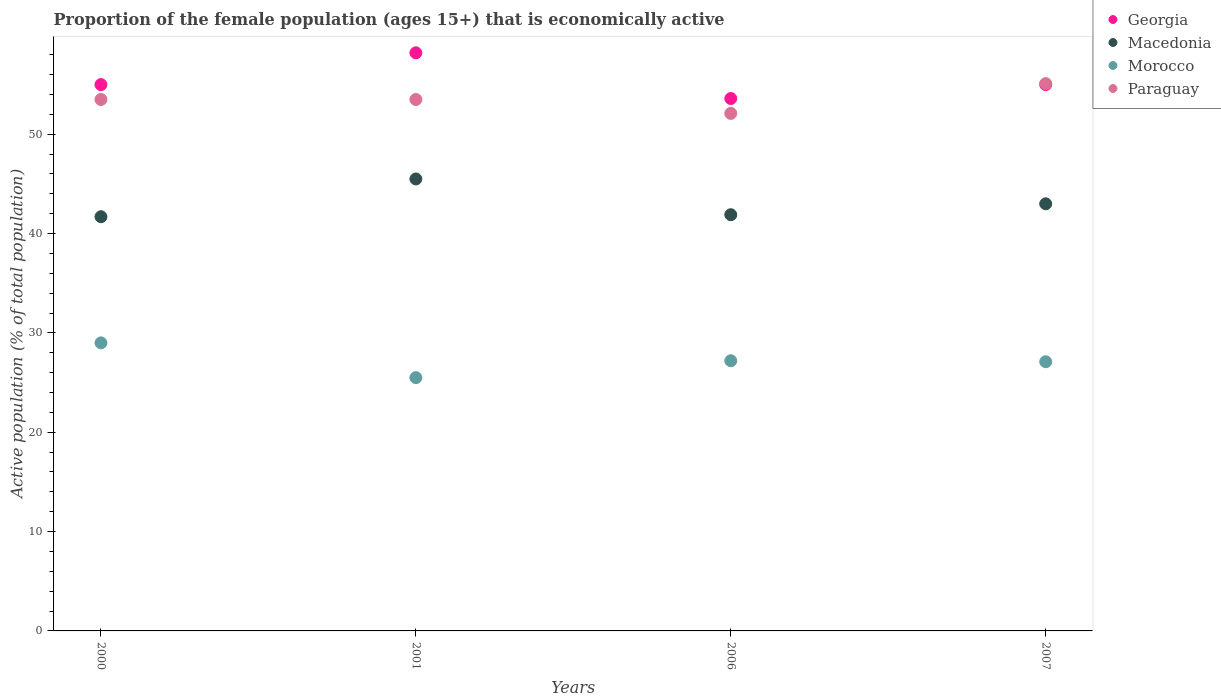How many different coloured dotlines are there?
Keep it short and to the point. 4. What is the proportion of the female population that is economically active in Paraguay in 2007?
Keep it short and to the point. 55.1. Across all years, what is the maximum proportion of the female population that is economically active in Georgia?
Ensure brevity in your answer.  58.2. Across all years, what is the minimum proportion of the female population that is economically active in Georgia?
Provide a succinct answer. 53.6. In which year was the proportion of the female population that is economically active in Paraguay minimum?
Provide a succinct answer. 2006. What is the total proportion of the female population that is economically active in Paraguay in the graph?
Give a very brief answer. 214.2. What is the difference between the proportion of the female population that is economically active in Macedonia in 2000 and that in 2007?
Offer a very short reply. -1.3. What is the difference between the proportion of the female population that is economically active in Macedonia in 2006 and the proportion of the female population that is economically active in Georgia in 2001?
Keep it short and to the point. -16.3. What is the average proportion of the female population that is economically active in Paraguay per year?
Offer a very short reply. 53.55. In the year 2001, what is the difference between the proportion of the female population that is economically active in Macedonia and proportion of the female population that is economically active in Georgia?
Your answer should be compact. -12.7. In how many years, is the proportion of the female population that is economically active in Georgia greater than 48 %?
Offer a very short reply. 4. What is the ratio of the proportion of the female population that is economically active in Georgia in 2001 to that in 2006?
Your answer should be compact. 1.09. What is the difference between the highest and the second highest proportion of the female population that is economically active in Georgia?
Make the answer very short. 3.2. What is the difference between the highest and the lowest proportion of the female population that is economically active in Georgia?
Offer a terse response. 4.6. How many dotlines are there?
Make the answer very short. 4. What is the difference between two consecutive major ticks on the Y-axis?
Provide a short and direct response. 10. Are the values on the major ticks of Y-axis written in scientific E-notation?
Provide a succinct answer. No. Does the graph contain any zero values?
Ensure brevity in your answer.  No. Where does the legend appear in the graph?
Offer a very short reply. Top right. How many legend labels are there?
Provide a short and direct response. 4. How are the legend labels stacked?
Your answer should be very brief. Vertical. What is the title of the graph?
Offer a terse response. Proportion of the female population (ages 15+) that is economically active. Does "Equatorial Guinea" appear as one of the legend labels in the graph?
Give a very brief answer. No. What is the label or title of the X-axis?
Your answer should be very brief. Years. What is the label or title of the Y-axis?
Provide a succinct answer. Active population (% of total population). What is the Active population (% of total population) in Macedonia in 2000?
Offer a terse response. 41.7. What is the Active population (% of total population) of Morocco in 2000?
Provide a succinct answer. 29. What is the Active population (% of total population) of Paraguay in 2000?
Your answer should be compact. 53.5. What is the Active population (% of total population) in Georgia in 2001?
Provide a short and direct response. 58.2. What is the Active population (% of total population) of Macedonia in 2001?
Your response must be concise. 45.5. What is the Active population (% of total population) of Morocco in 2001?
Your answer should be very brief. 25.5. What is the Active population (% of total population) of Paraguay in 2001?
Offer a terse response. 53.5. What is the Active population (% of total population) in Georgia in 2006?
Your answer should be very brief. 53.6. What is the Active population (% of total population) of Macedonia in 2006?
Your response must be concise. 41.9. What is the Active population (% of total population) of Morocco in 2006?
Give a very brief answer. 27.2. What is the Active population (% of total population) of Paraguay in 2006?
Provide a succinct answer. 52.1. What is the Active population (% of total population) in Macedonia in 2007?
Keep it short and to the point. 43. What is the Active population (% of total population) of Morocco in 2007?
Provide a short and direct response. 27.1. What is the Active population (% of total population) of Paraguay in 2007?
Make the answer very short. 55.1. Across all years, what is the maximum Active population (% of total population) of Georgia?
Provide a succinct answer. 58.2. Across all years, what is the maximum Active population (% of total population) in Macedonia?
Your answer should be very brief. 45.5. Across all years, what is the maximum Active population (% of total population) in Paraguay?
Keep it short and to the point. 55.1. Across all years, what is the minimum Active population (% of total population) of Georgia?
Make the answer very short. 53.6. Across all years, what is the minimum Active population (% of total population) in Macedonia?
Your answer should be very brief. 41.7. Across all years, what is the minimum Active population (% of total population) of Paraguay?
Your answer should be compact. 52.1. What is the total Active population (% of total population) of Georgia in the graph?
Your answer should be compact. 221.8. What is the total Active population (% of total population) of Macedonia in the graph?
Provide a short and direct response. 172.1. What is the total Active population (% of total population) in Morocco in the graph?
Keep it short and to the point. 108.8. What is the total Active population (% of total population) of Paraguay in the graph?
Your response must be concise. 214.2. What is the difference between the Active population (% of total population) in Georgia in 2000 and that in 2001?
Your answer should be compact. -3.2. What is the difference between the Active population (% of total population) of Morocco in 2000 and that in 2001?
Keep it short and to the point. 3.5. What is the difference between the Active population (% of total population) of Georgia in 2000 and that in 2006?
Your answer should be compact. 1.4. What is the difference between the Active population (% of total population) in Macedonia in 2000 and that in 2006?
Your response must be concise. -0.2. What is the difference between the Active population (% of total population) in Morocco in 2000 and that in 2006?
Keep it short and to the point. 1.8. What is the difference between the Active population (% of total population) of Paraguay in 2000 and that in 2006?
Your answer should be compact. 1.4. What is the difference between the Active population (% of total population) in Georgia in 2000 and that in 2007?
Give a very brief answer. 0. What is the difference between the Active population (% of total population) in Morocco in 2000 and that in 2007?
Your answer should be very brief. 1.9. What is the difference between the Active population (% of total population) in Paraguay in 2000 and that in 2007?
Provide a short and direct response. -1.6. What is the difference between the Active population (% of total population) in Georgia in 2001 and that in 2006?
Give a very brief answer. 4.6. What is the difference between the Active population (% of total population) of Macedonia in 2001 and that in 2006?
Ensure brevity in your answer.  3.6. What is the difference between the Active population (% of total population) in Paraguay in 2001 and that in 2006?
Offer a terse response. 1.4. What is the difference between the Active population (% of total population) in Paraguay in 2001 and that in 2007?
Keep it short and to the point. -1.6. What is the difference between the Active population (% of total population) of Georgia in 2006 and that in 2007?
Your answer should be compact. -1.4. What is the difference between the Active population (% of total population) of Macedonia in 2006 and that in 2007?
Give a very brief answer. -1.1. What is the difference between the Active population (% of total population) of Morocco in 2006 and that in 2007?
Your answer should be compact. 0.1. What is the difference between the Active population (% of total population) in Paraguay in 2006 and that in 2007?
Give a very brief answer. -3. What is the difference between the Active population (% of total population) in Georgia in 2000 and the Active population (% of total population) in Macedonia in 2001?
Offer a very short reply. 9.5. What is the difference between the Active population (% of total population) of Georgia in 2000 and the Active population (% of total population) of Morocco in 2001?
Provide a short and direct response. 29.5. What is the difference between the Active population (% of total population) of Georgia in 2000 and the Active population (% of total population) of Paraguay in 2001?
Your answer should be very brief. 1.5. What is the difference between the Active population (% of total population) of Macedonia in 2000 and the Active population (% of total population) of Paraguay in 2001?
Keep it short and to the point. -11.8. What is the difference between the Active population (% of total population) of Morocco in 2000 and the Active population (% of total population) of Paraguay in 2001?
Provide a succinct answer. -24.5. What is the difference between the Active population (% of total population) of Georgia in 2000 and the Active population (% of total population) of Macedonia in 2006?
Offer a very short reply. 13.1. What is the difference between the Active population (% of total population) of Georgia in 2000 and the Active population (% of total population) of Morocco in 2006?
Your response must be concise. 27.8. What is the difference between the Active population (% of total population) of Georgia in 2000 and the Active population (% of total population) of Paraguay in 2006?
Offer a terse response. 2.9. What is the difference between the Active population (% of total population) in Macedonia in 2000 and the Active population (% of total population) in Morocco in 2006?
Offer a terse response. 14.5. What is the difference between the Active population (% of total population) in Macedonia in 2000 and the Active population (% of total population) in Paraguay in 2006?
Offer a terse response. -10.4. What is the difference between the Active population (% of total population) of Morocco in 2000 and the Active population (% of total population) of Paraguay in 2006?
Give a very brief answer. -23.1. What is the difference between the Active population (% of total population) in Georgia in 2000 and the Active population (% of total population) in Macedonia in 2007?
Your answer should be very brief. 12. What is the difference between the Active population (% of total population) of Georgia in 2000 and the Active population (% of total population) of Morocco in 2007?
Give a very brief answer. 27.9. What is the difference between the Active population (% of total population) in Georgia in 2000 and the Active population (% of total population) in Paraguay in 2007?
Ensure brevity in your answer.  -0.1. What is the difference between the Active population (% of total population) in Macedonia in 2000 and the Active population (% of total population) in Paraguay in 2007?
Provide a short and direct response. -13.4. What is the difference between the Active population (% of total population) in Morocco in 2000 and the Active population (% of total population) in Paraguay in 2007?
Offer a very short reply. -26.1. What is the difference between the Active population (% of total population) of Georgia in 2001 and the Active population (% of total population) of Morocco in 2006?
Give a very brief answer. 31. What is the difference between the Active population (% of total population) of Georgia in 2001 and the Active population (% of total population) of Paraguay in 2006?
Provide a succinct answer. 6.1. What is the difference between the Active population (% of total population) of Macedonia in 2001 and the Active population (% of total population) of Morocco in 2006?
Provide a short and direct response. 18.3. What is the difference between the Active population (% of total population) in Morocco in 2001 and the Active population (% of total population) in Paraguay in 2006?
Offer a very short reply. -26.6. What is the difference between the Active population (% of total population) of Georgia in 2001 and the Active population (% of total population) of Macedonia in 2007?
Provide a short and direct response. 15.2. What is the difference between the Active population (% of total population) in Georgia in 2001 and the Active population (% of total population) in Morocco in 2007?
Offer a terse response. 31.1. What is the difference between the Active population (% of total population) of Georgia in 2001 and the Active population (% of total population) of Paraguay in 2007?
Ensure brevity in your answer.  3.1. What is the difference between the Active population (% of total population) in Macedonia in 2001 and the Active population (% of total population) in Morocco in 2007?
Your answer should be compact. 18.4. What is the difference between the Active population (% of total population) in Macedonia in 2001 and the Active population (% of total population) in Paraguay in 2007?
Ensure brevity in your answer.  -9.6. What is the difference between the Active population (% of total population) of Morocco in 2001 and the Active population (% of total population) of Paraguay in 2007?
Provide a short and direct response. -29.6. What is the difference between the Active population (% of total population) of Georgia in 2006 and the Active population (% of total population) of Morocco in 2007?
Provide a short and direct response. 26.5. What is the difference between the Active population (% of total population) in Macedonia in 2006 and the Active population (% of total population) in Morocco in 2007?
Offer a very short reply. 14.8. What is the difference between the Active population (% of total population) of Macedonia in 2006 and the Active population (% of total population) of Paraguay in 2007?
Your answer should be compact. -13.2. What is the difference between the Active population (% of total population) of Morocco in 2006 and the Active population (% of total population) of Paraguay in 2007?
Your response must be concise. -27.9. What is the average Active population (% of total population) in Georgia per year?
Your answer should be very brief. 55.45. What is the average Active population (% of total population) of Macedonia per year?
Your answer should be very brief. 43.02. What is the average Active population (% of total population) in Morocco per year?
Your response must be concise. 27.2. What is the average Active population (% of total population) in Paraguay per year?
Make the answer very short. 53.55. In the year 2000, what is the difference between the Active population (% of total population) in Georgia and Active population (% of total population) in Macedonia?
Give a very brief answer. 13.3. In the year 2000, what is the difference between the Active population (% of total population) of Georgia and Active population (% of total population) of Morocco?
Your answer should be compact. 26. In the year 2000, what is the difference between the Active population (% of total population) of Macedonia and Active population (% of total population) of Morocco?
Offer a terse response. 12.7. In the year 2000, what is the difference between the Active population (% of total population) of Morocco and Active population (% of total population) of Paraguay?
Give a very brief answer. -24.5. In the year 2001, what is the difference between the Active population (% of total population) of Georgia and Active population (% of total population) of Morocco?
Provide a short and direct response. 32.7. In the year 2001, what is the difference between the Active population (% of total population) of Georgia and Active population (% of total population) of Paraguay?
Keep it short and to the point. 4.7. In the year 2001, what is the difference between the Active population (% of total population) in Macedonia and Active population (% of total population) in Morocco?
Provide a succinct answer. 20. In the year 2001, what is the difference between the Active population (% of total population) of Morocco and Active population (% of total population) of Paraguay?
Make the answer very short. -28. In the year 2006, what is the difference between the Active population (% of total population) of Georgia and Active population (% of total population) of Morocco?
Ensure brevity in your answer.  26.4. In the year 2006, what is the difference between the Active population (% of total population) in Macedonia and Active population (% of total population) in Paraguay?
Offer a terse response. -10.2. In the year 2006, what is the difference between the Active population (% of total population) of Morocco and Active population (% of total population) of Paraguay?
Your response must be concise. -24.9. In the year 2007, what is the difference between the Active population (% of total population) in Georgia and Active population (% of total population) in Macedonia?
Ensure brevity in your answer.  12. In the year 2007, what is the difference between the Active population (% of total population) of Georgia and Active population (% of total population) of Morocco?
Offer a terse response. 27.9. In the year 2007, what is the difference between the Active population (% of total population) of Georgia and Active population (% of total population) of Paraguay?
Provide a short and direct response. -0.1. In the year 2007, what is the difference between the Active population (% of total population) of Macedonia and Active population (% of total population) of Morocco?
Offer a very short reply. 15.9. What is the ratio of the Active population (% of total population) in Georgia in 2000 to that in 2001?
Your answer should be compact. 0.94. What is the ratio of the Active population (% of total population) of Macedonia in 2000 to that in 2001?
Give a very brief answer. 0.92. What is the ratio of the Active population (% of total population) of Morocco in 2000 to that in 2001?
Your answer should be very brief. 1.14. What is the ratio of the Active population (% of total population) in Paraguay in 2000 to that in 2001?
Your answer should be compact. 1. What is the ratio of the Active population (% of total population) of Georgia in 2000 to that in 2006?
Give a very brief answer. 1.03. What is the ratio of the Active population (% of total population) in Macedonia in 2000 to that in 2006?
Your answer should be very brief. 1. What is the ratio of the Active population (% of total population) of Morocco in 2000 to that in 2006?
Your response must be concise. 1.07. What is the ratio of the Active population (% of total population) of Paraguay in 2000 to that in 2006?
Give a very brief answer. 1.03. What is the ratio of the Active population (% of total population) of Macedonia in 2000 to that in 2007?
Your answer should be compact. 0.97. What is the ratio of the Active population (% of total population) of Morocco in 2000 to that in 2007?
Your answer should be very brief. 1.07. What is the ratio of the Active population (% of total population) in Georgia in 2001 to that in 2006?
Your answer should be compact. 1.09. What is the ratio of the Active population (% of total population) in Macedonia in 2001 to that in 2006?
Ensure brevity in your answer.  1.09. What is the ratio of the Active population (% of total population) in Morocco in 2001 to that in 2006?
Offer a very short reply. 0.94. What is the ratio of the Active population (% of total population) of Paraguay in 2001 to that in 2006?
Offer a very short reply. 1.03. What is the ratio of the Active population (% of total population) in Georgia in 2001 to that in 2007?
Provide a succinct answer. 1.06. What is the ratio of the Active population (% of total population) of Macedonia in 2001 to that in 2007?
Provide a short and direct response. 1.06. What is the ratio of the Active population (% of total population) of Morocco in 2001 to that in 2007?
Ensure brevity in your answer.  0.94. What is the ratio of the Active population (% of total population) in Georgia in 2006 to that in 2007?
Keep it short and to the point. 0.97. What is the ratio of the Active population (% of total population) of Macedonia in 2006 to that in 2007?
Your answer should be very brief. 0.97. What is the ratio of the Active population (% of total population) of Paraguay in 2006 to that in 2007?
Offer a terse response. 0.95. What is the difference between the highest and the second highest Active population (% of total population) of Georgia?
Offer a terse response. 3.2. What is the difference between the highest and the second highest Active population (% of total population) of Morocco?
Your answer should be very brief. 1.8. What is the difference between the highest and the lowest Active population (% of total population) in Georgia?
Offer a very short reply. 4.6. What is the difference between the highest and the lowest Active population (% of total population) in Morocco?
Provide a short and direct response. 3.5. 